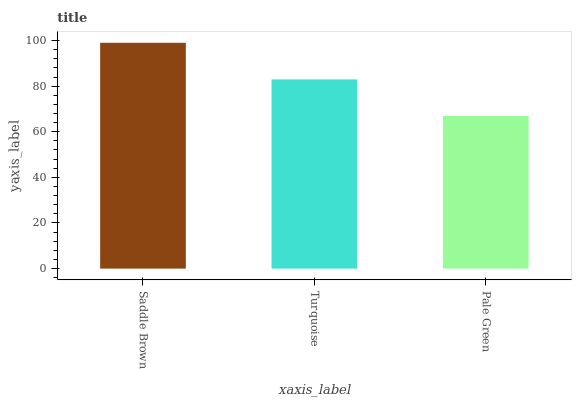Is Turquoise the minimum?
Answer yes or no. No. Is Turquoise the maximum?
Answer yes or no. No. Is Saddle Brown greater than Turquoise?
Answer yes or no. Yes. Is Turquoise less than Saddle Brown?
Answer yes or no. Yes. Is Turquoise greater than Saddle Brown?
Answer yes or no. No. Is Saddle Brown less than Turquoise?
Answer yes or no. No. Is Turquoise the high median?
Answer yes or no. Yes. Is Turquoise the low median?
Answer yes or no. Yes. Is Pale Green the high median?
Answer yes or no. No. Is Pale Green the low median?
Answer yes or no. No. 